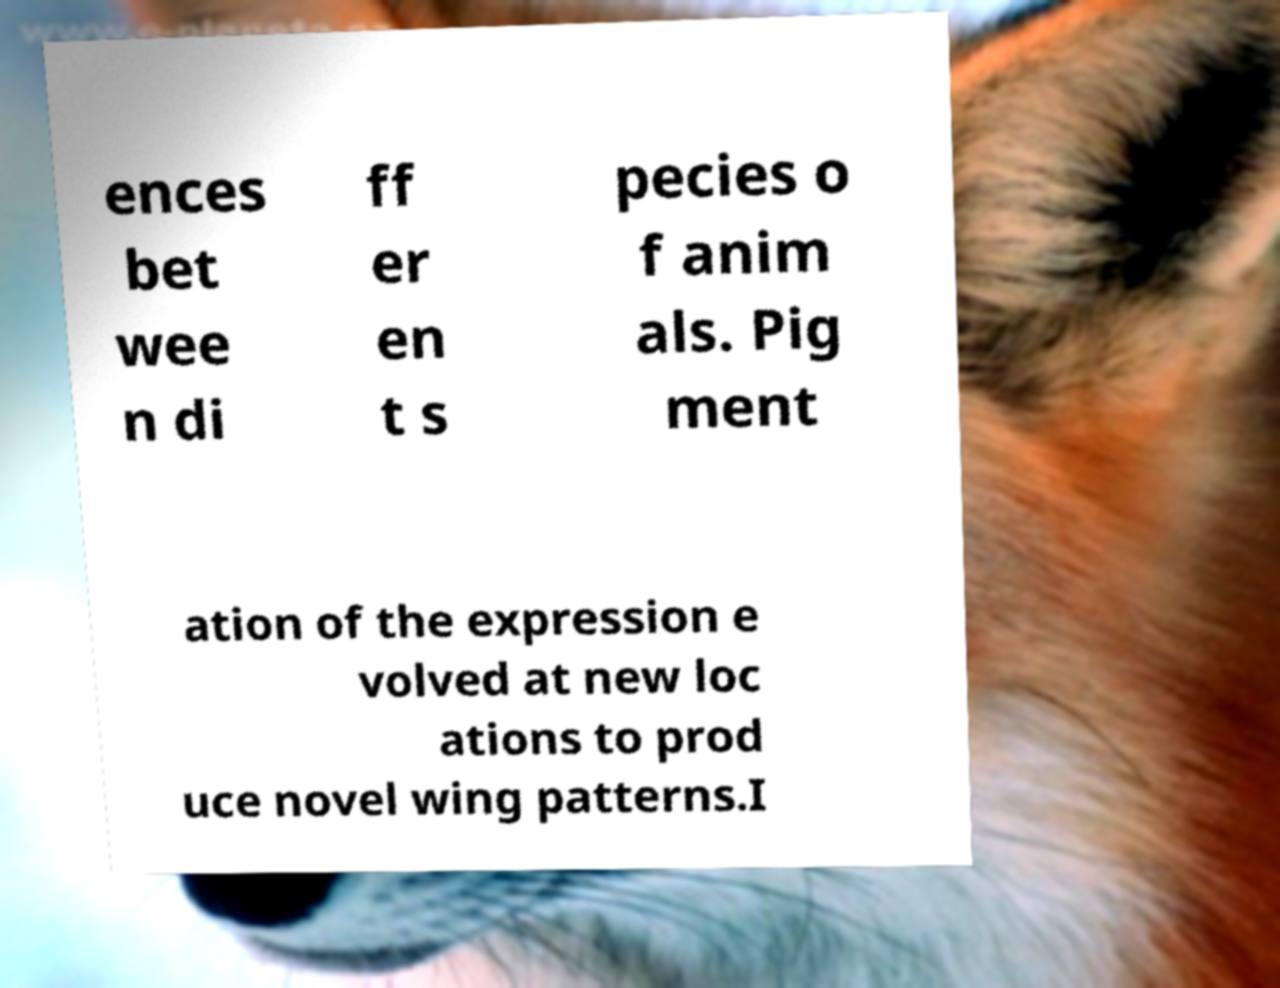Could you assist in decoding the text presented in this image and type it out clearly? ences bet wee n di ff er en t s pecies o f anim als. Pig ment ation of the expression e volved at new loc ations to prod uce novel wing patterns.I 